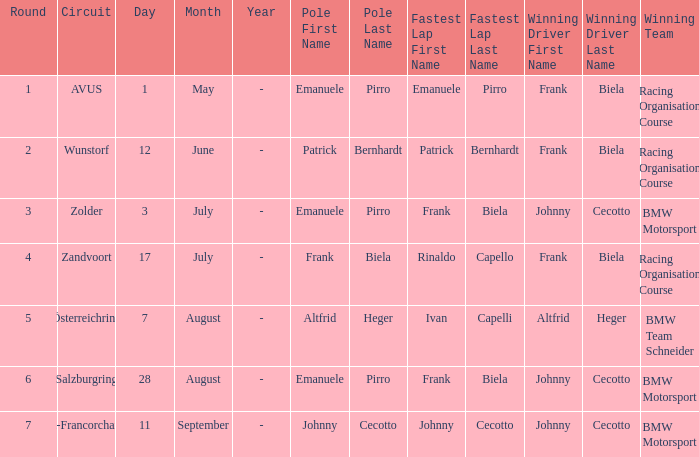What stage was circuit avus? 1.0. Can you parse all the data within this table? {'header': ['Round', 'Circuit', 'Day', 'Month', 'Year', 'Pole First Name', 'Pole Last Name', 'Fastest Lap First Name', 'Fastest Lap Last Name', 'Winning Driver First Name', 'Winning Driver Last Name', 'Winning Team'], 'rows': [['1', 'AVUS', '1', 'May', '-', 'Emanuele', 'Pirro', 'Emanuele', 'Pirro', 'Frank', 'Biela', 'Racing Organisation Course'], ['2', 'Wunstorf', '12', 'June', '-', 'Patrick', 'Bernhardt', 'Patrick', 'Bernhardt', 'Frank', 'Biela', 'Racing Organisation Course'], ['3', 'Zolder', '3', 'July', '-', 'Emanuele', 'Pirro', 'Frank', 'Biela', 'Johnny', 'Cecotto', 'BMW Motorsport'], ['4', 'Zandvoort', '17', 'July', '-', 'Frank', 'Biela', 'Rinaldo', 'Capello', 'Frank', 'Biela', 'Racing Organisation Course'], ['5', 'Österreichring', '7', 'August', '-', 'Altfrid', 'Heger', 'Ivan', 'Capelli', 'Altfrid', 'Heger', 'BMW Team Schneider'], ['6', 'Salzburgring', '28', 'August', '-', 'Emanuele', 'Pirro', 'Frank', 'Biela', 'Johnny', 'Cecotto', 'BMW Motorsport'], ['7', 'Spa-Francorchamps', '11', 'September', '-', 'Johnny', 'Cecotto', 'Johnny', 'Cecotto', 'Johnny', 'Cecotto', 'BMW Motorsport']]} 